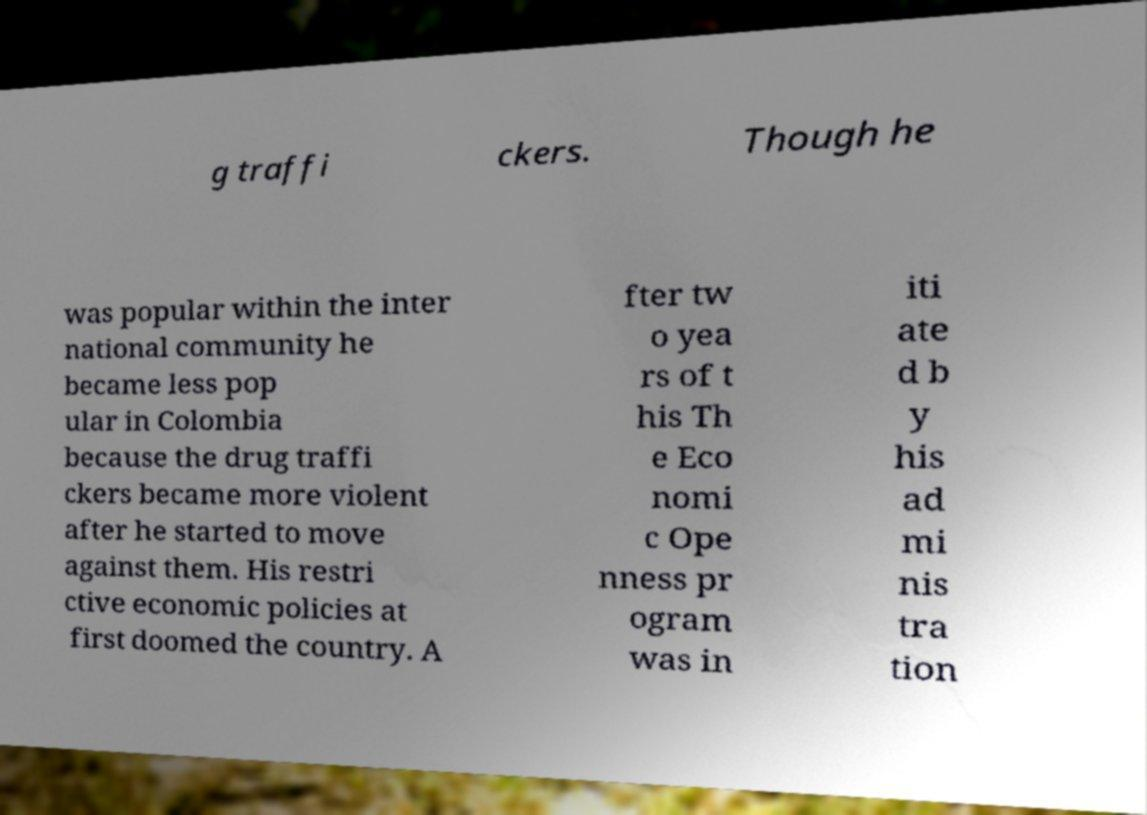For documentation purposes, I need the text within this image transcribed. Could you provide that? g traffi ckers. Though he was popular within the inter national community he became less pop ular in Colombia because the drug traffi ckers became more violent after he started to move against them. His restri ctive economic policies at first doomed the country. A fter tw o yea rs of t his Th e Eco nomi c Ope nness pr ogram was in iti ate d b y his ad mi nis tra tion 